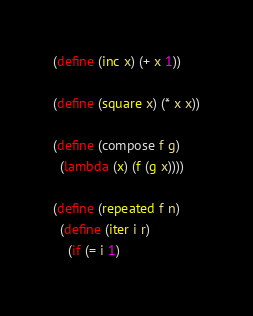Convert code to text. <code><loc_0><loc_0><loc_500><loc_500><_Scheme_>(define (inc x) (+ x 1))

(define (square x) (* x x))

(define (compose f g)
  (lambda (x) (f (g x))))

(define (repeated f n)
  (define (iter i r)
    (if (= i 1)</code> 